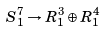Convert formula to latex. <formula><loc_0><loc_0><loc_500><loc_500>S ^ { 7 } _ { 1 } \rightarrow { R } ^ { 3 } _ { 1 } \oplus { R } ^ { 4 } _ { 1 }</formula> 